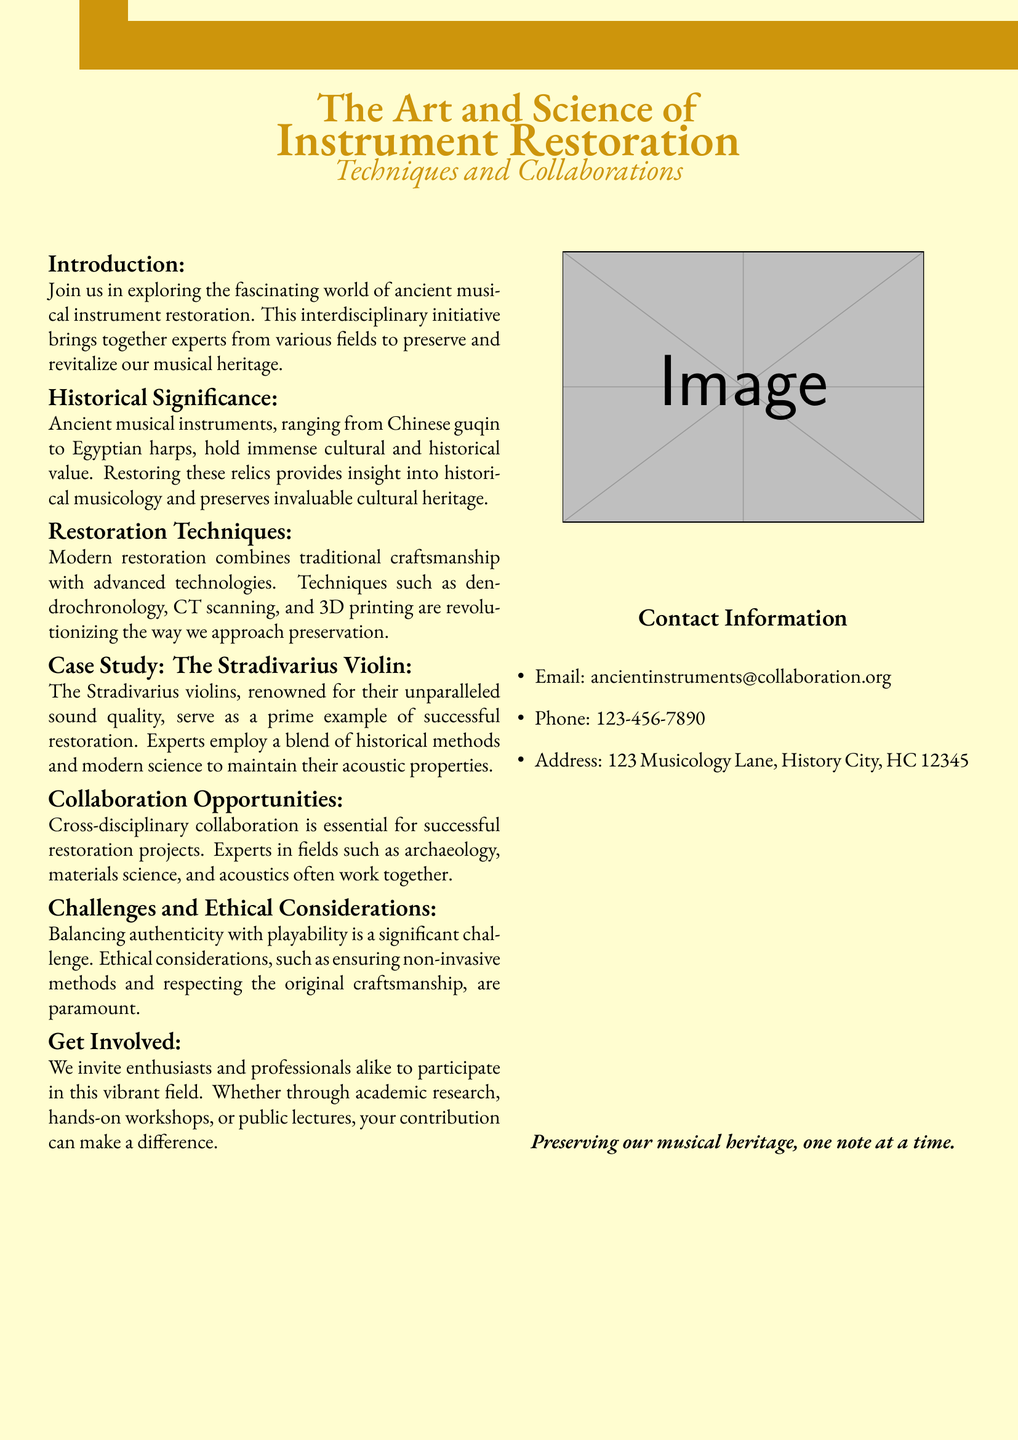What is the title of the event? The title of the event is prominently displayed at the top of the document, stating the focus on instrument restoration.
Answer: The Art and Science of Instrument Restoration What is the historical significance of ancient musical instruments? The document discusses the immense cultural and historical value of ancient musical instruments, emphasizing their role in historical musicology.
Answer: Cultural and historical value Which instrument is used as a case study? The specific instrument highlighted in the case study section demonstrates examples of restoration techniques, making it a focal point of interest.
Answer: The Stradivarius Violin What restoration techniques are mentioned? The document lists multiple modern restoration techniques that blend traditional methods with advanced technology, providing insight into preservation efforts.
Answer: Dendrochronology, CT scanning, and 3D printing What collaboration fields are emphasized? The text specifies various fields that contribute to successful restoration projects, indicating the interdisciplinary nature of the initiative.
Answer: Archaeology, materials science, and acoustics What is a significant challenge in restoration? The challenge listed in the document highlights a common dilemma faced by restorers, reflecting on the balance needed in their approach.
Answer: Balancing authenticity with playability 